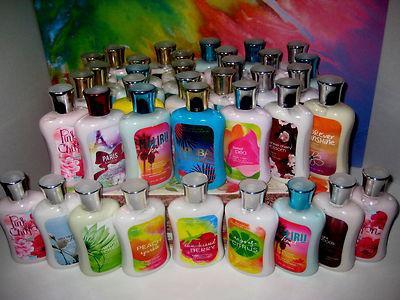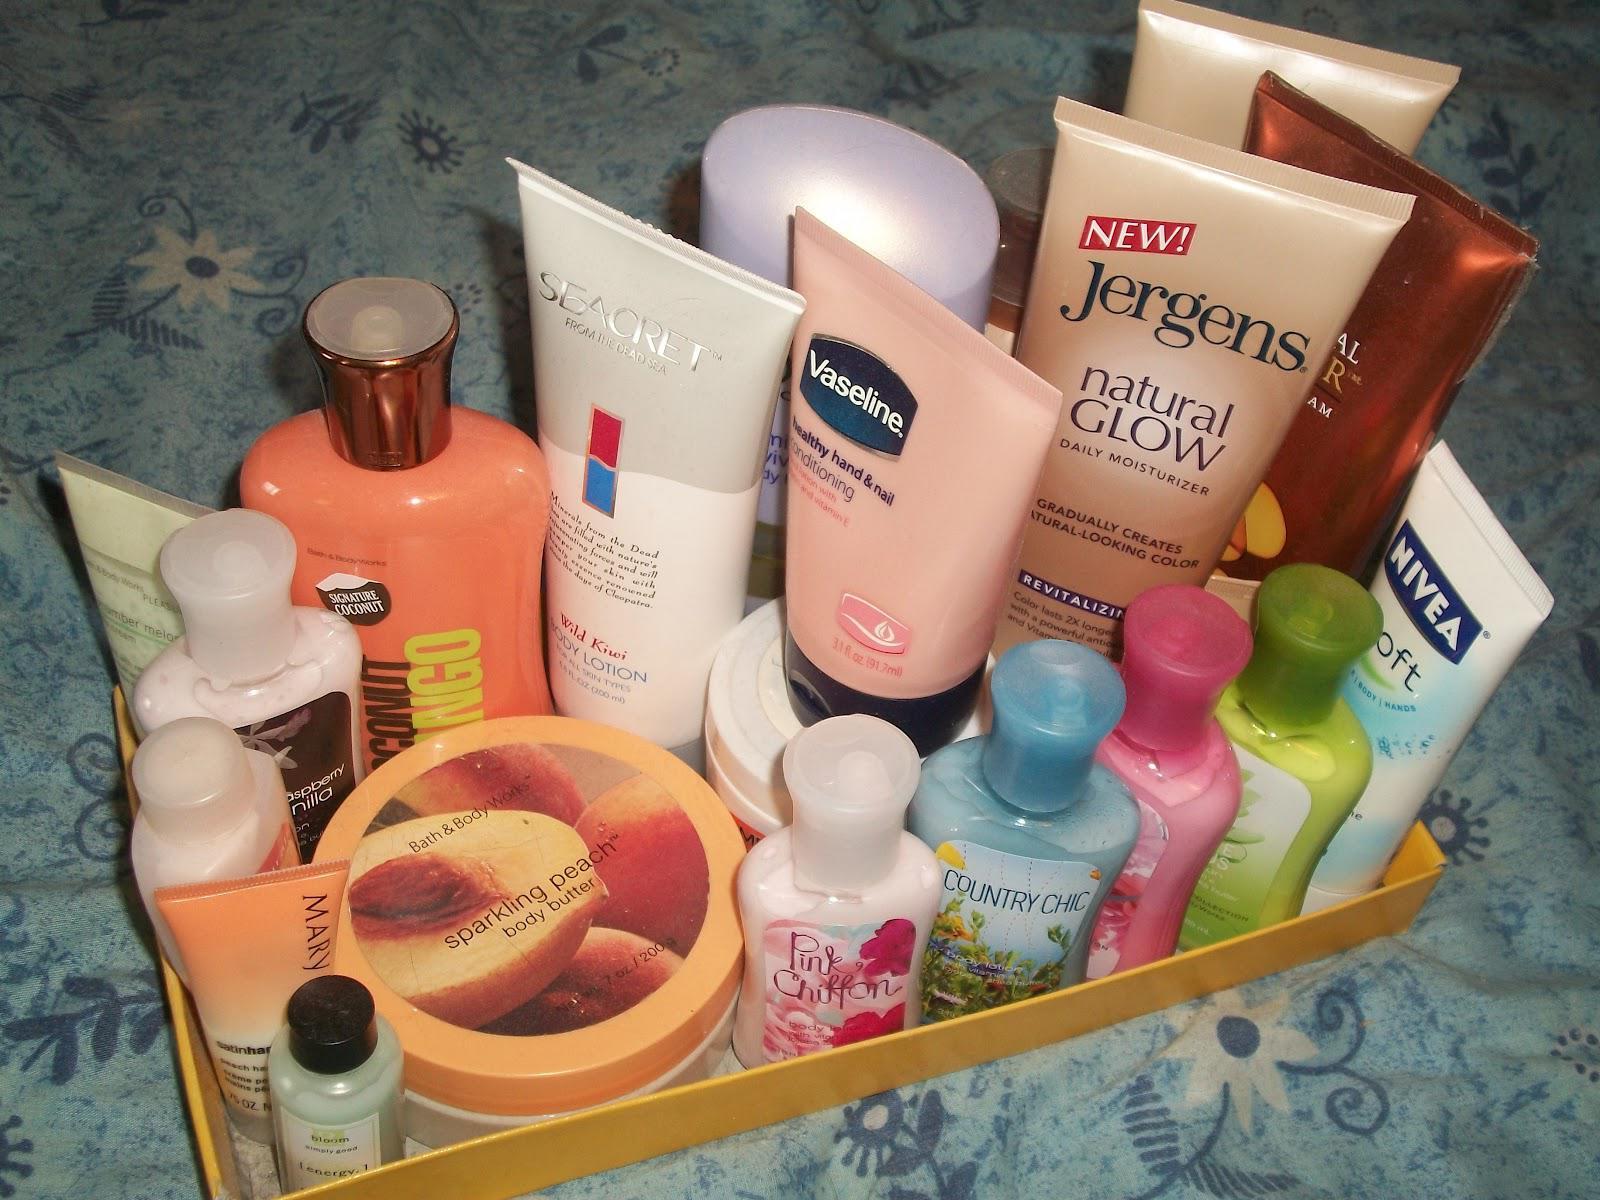The first image is the image on the left, the second image is the image on the right. Considering the images on both sides, is "The bottles in the image on the left are stacked in a tiered display." valid? Answer yes or no. Yes. 